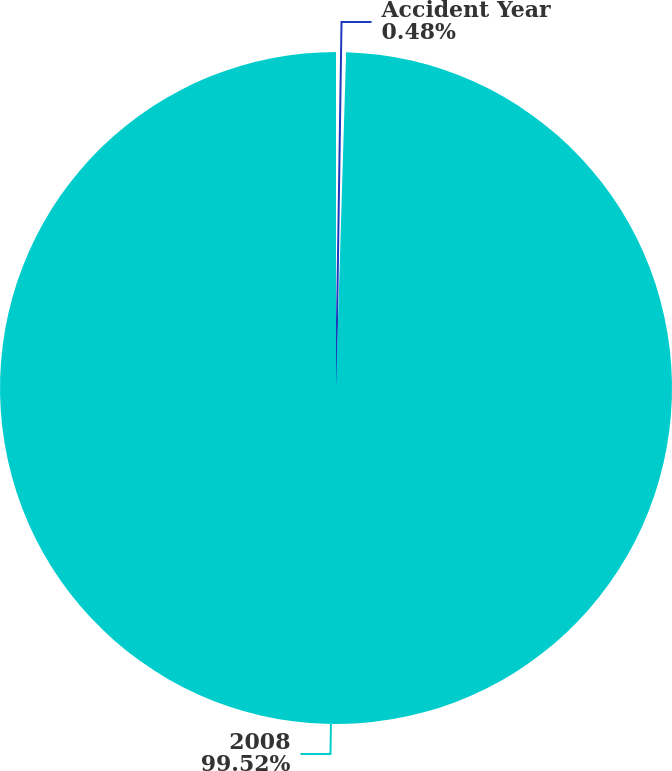Convert chart to OTSL. <chart><loc_0><loc_0><loc_500><loc_500><pie_chart><fcel>Accident Year<fcel>2008<nl><fcel>0.48%<fcel>99.52%<nl></chart> 